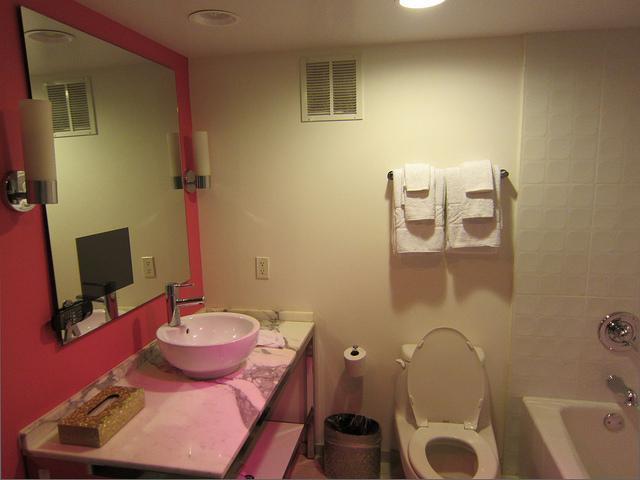What electronic device is embedded within the bathroom mirror in this bathroom?
Answer the question by selecting the correct answer among the 4 following choices and explain your choice with a short sentence. The answer should be formatted with the following format: `Answer: choice
Rationale: rationale.`
Options: Phone, television, heater, light. Answer: television.
Rationale: There is a small screen in the mirror. 